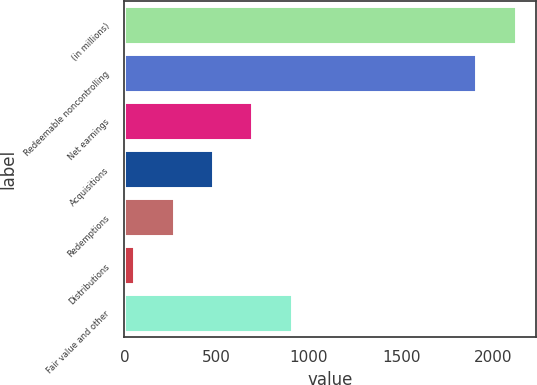Convert chart to OTSL. <chart><loc_0><loc_0><loc_500><loc_500><bar_chart><fcel>(in millions)<fcel>Redeemable noncontrolling<fcel>Net earnings<fcel>Acquisitions<fcel>Redemptions<fcel>Distributions<fcel>Fair value and other<nl><fcel>2121.6<fcel>1908<fcel>693.8<fcel>480.2<fcel>266.6<fcel>53<fcel>907.4<nl></chart> 